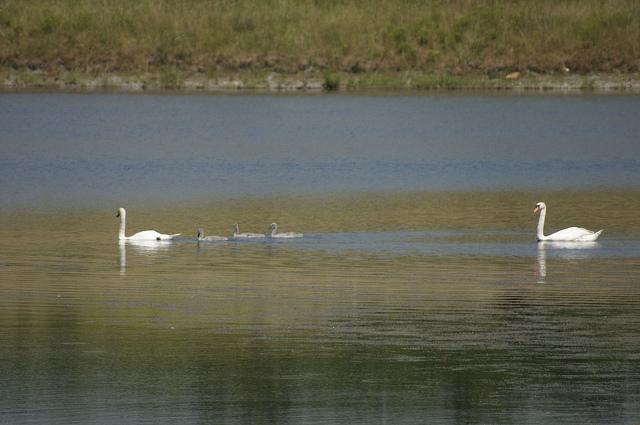What number of animals are in this body of water?
Give a very brief answer. 5. How many ducklings are in the water?
Short answer required. 3. Is this a river?
Concise answer only. Yes. Are these pelicans?
Short answer required. No. Do all the birds in this photo appear to be the same species?
Quick response, please. Yes. What human emotion do these birds often represent?
Be succinct. Calm. What kind of bird is this?
Give a very brief answer. Swan. Do you see any wild animals?
Answer briefly. Yes. Are the birds swimming?
Answer briefly. Yes. How many birds can be spotted here?
Give a very brief answer. 5. What kind of bird are these?
Give a very brief answer. Swans. How many birds are there?
Give a very brief answer. 5. What is the bird about to do?
Give a very brief answer. Swim. What kind of bird is on the right?
Short answer required. Swan. 